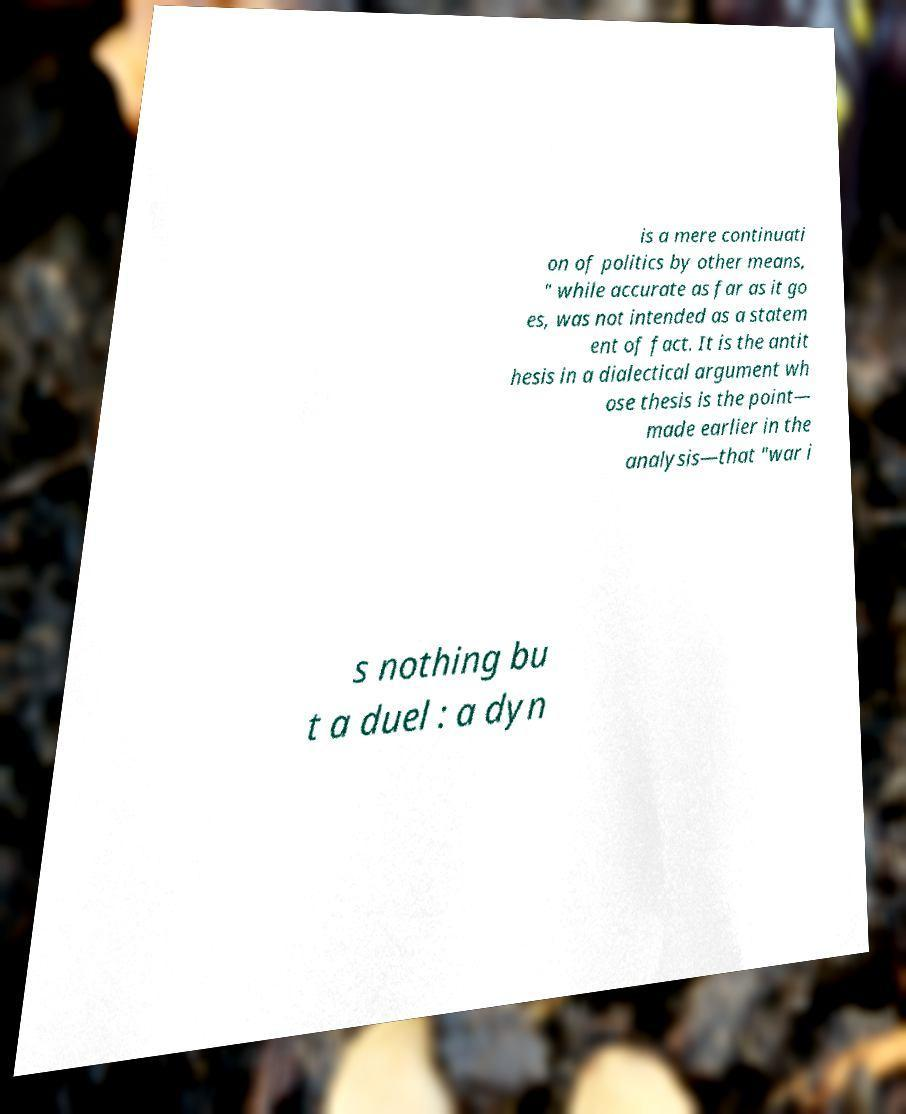Could you extract and type out the text from this image? is a mere continuati on of politics by other means, " while accurate as far as it go es, was not intended as a statem ent of fact. It is the antit hesis in a dialectical argument wh ose thesis is the point— made earlier in the analysis—that "war i s nothing bu t a duel : a dyn 